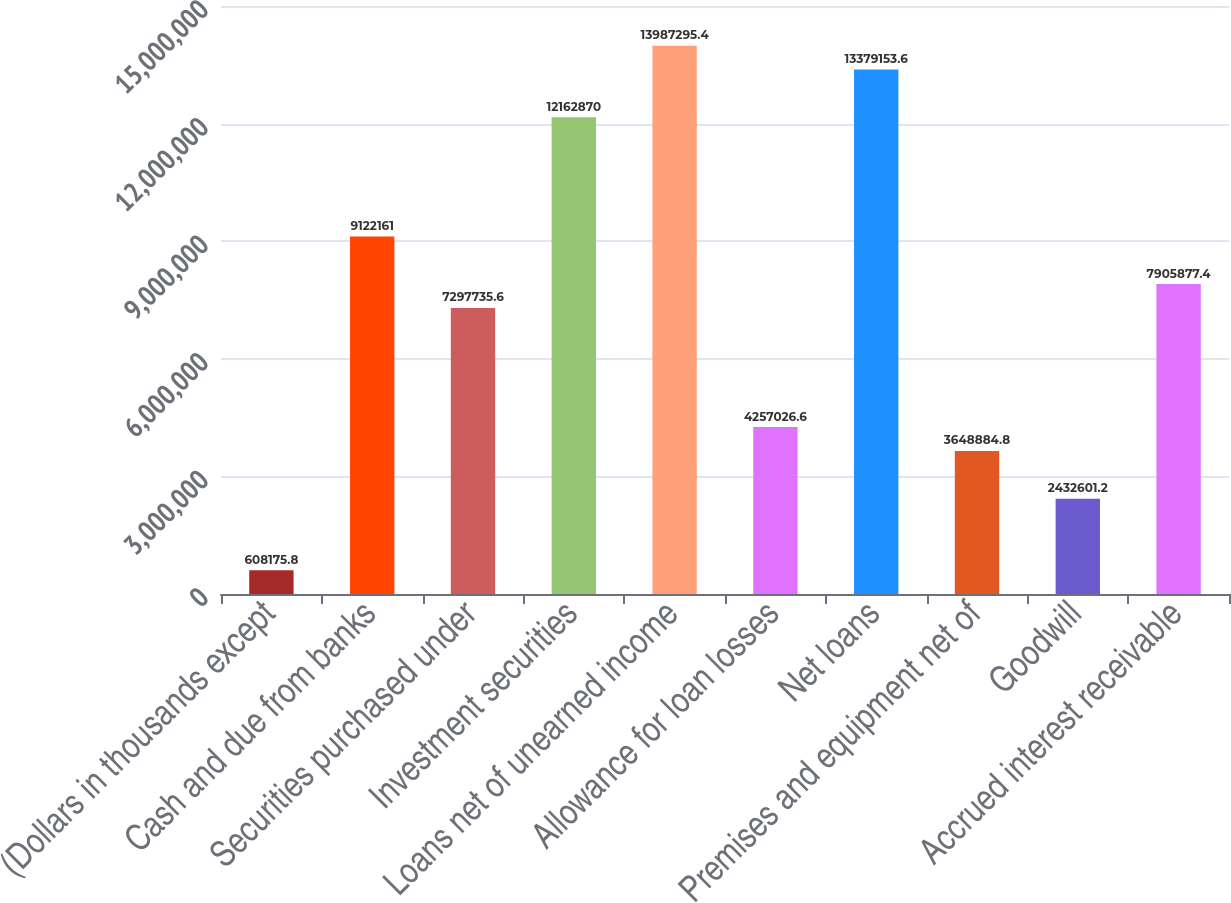Convert chart. <chart><loc_0><loc_0><loc_500><loc_500><bar_chart><fcel>(Dollars in thousands except<fcel>Cash and due from banks<fcel>Securities purchased under<fcel>Investment securities<fcel>Loans net of unearned income<fcel>Allowance for loan losses<fcel>Net loans<fcel>Premises and equipment net of<fcel>Goodwill<fcel>Accrued interest receivable<nl><fcel>608176<fcel>9.12216e+06<fcel>7.29774e+06<fcel>1.21629e+07<fcel>1.39873e+07<fcel>4.25703e+06<fcel>1.33792e+07<fcel>3.64888e+06<fcel>2.4326e+06<fcel>7.90588e+06<nl></chart> 